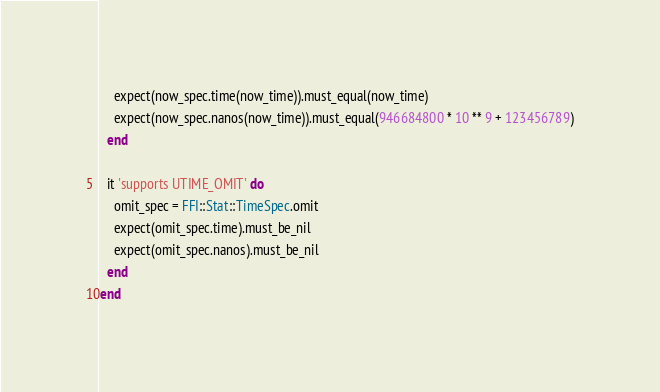<code> <loc_0><loc_0><loc_500><loc_500><_Ruby_>    expect(now_spec.time(now_time)).must_equal(now_time)
    expect(now_spec.nanos(now_time)).must_equal(946684800 * 10 ** 9 + 123456789)
  end

  it 'supports UTIME_OMIT' do
    omit_spec = FFI::Stat::TimeSpec.omit
    expect(omit_spec.time).must_be_nil
    expect(omit_spec.nanos).must_be_nil
  end
end
</code> 